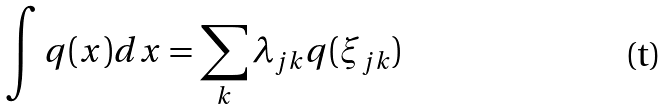Convert formula to latex. <formula><loc_0><loc_0><loc_500><loc_500>\int q ( x ) d x = \sum _ { k } \lambda _ { j k } q ( \xi _ { j k } )</formula> 